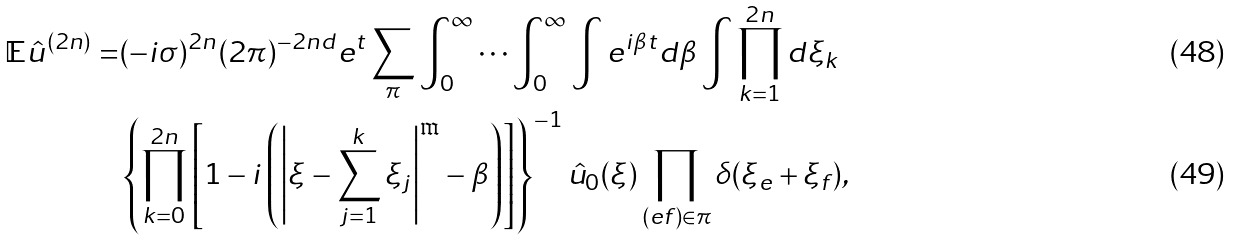Convert formula to latex. <formula><loc_0><loc_0><loc_500><loc_500>\mathbb { E } \hat { u } ^ { ( 2 n ) } = & ( - i \sigma ) ^ { 2 n } ( 2 \pi ) ^ { - 2 n d } e ^ { t } \sum _ { \pi } \int _ { 0 } ^ { \infty } \cdots \int _ { 0 } ^ { \infty } \int e ^ { i \beta t } d \beta \int \prod _ { k = 1 } ^ { 2 n } d \xi _ { k } \\ & \left \{ \prod _ { k = 0 } ^ { 2 n } \left [ 1 - i \left ( \left | \xi - \sum _ { j = 1 } ^ { k } \xi _ { j } \right | ^ { \mathfrak { m } } - \beta \right ) \right ] \right \} ^ { - 1 } \hat { u } _ { 0 } ( \xi ) \prod _ { ( e f ) \in \pi } \delta ( \xi _ { e } + \xi _ { f } ) ,</formula> 